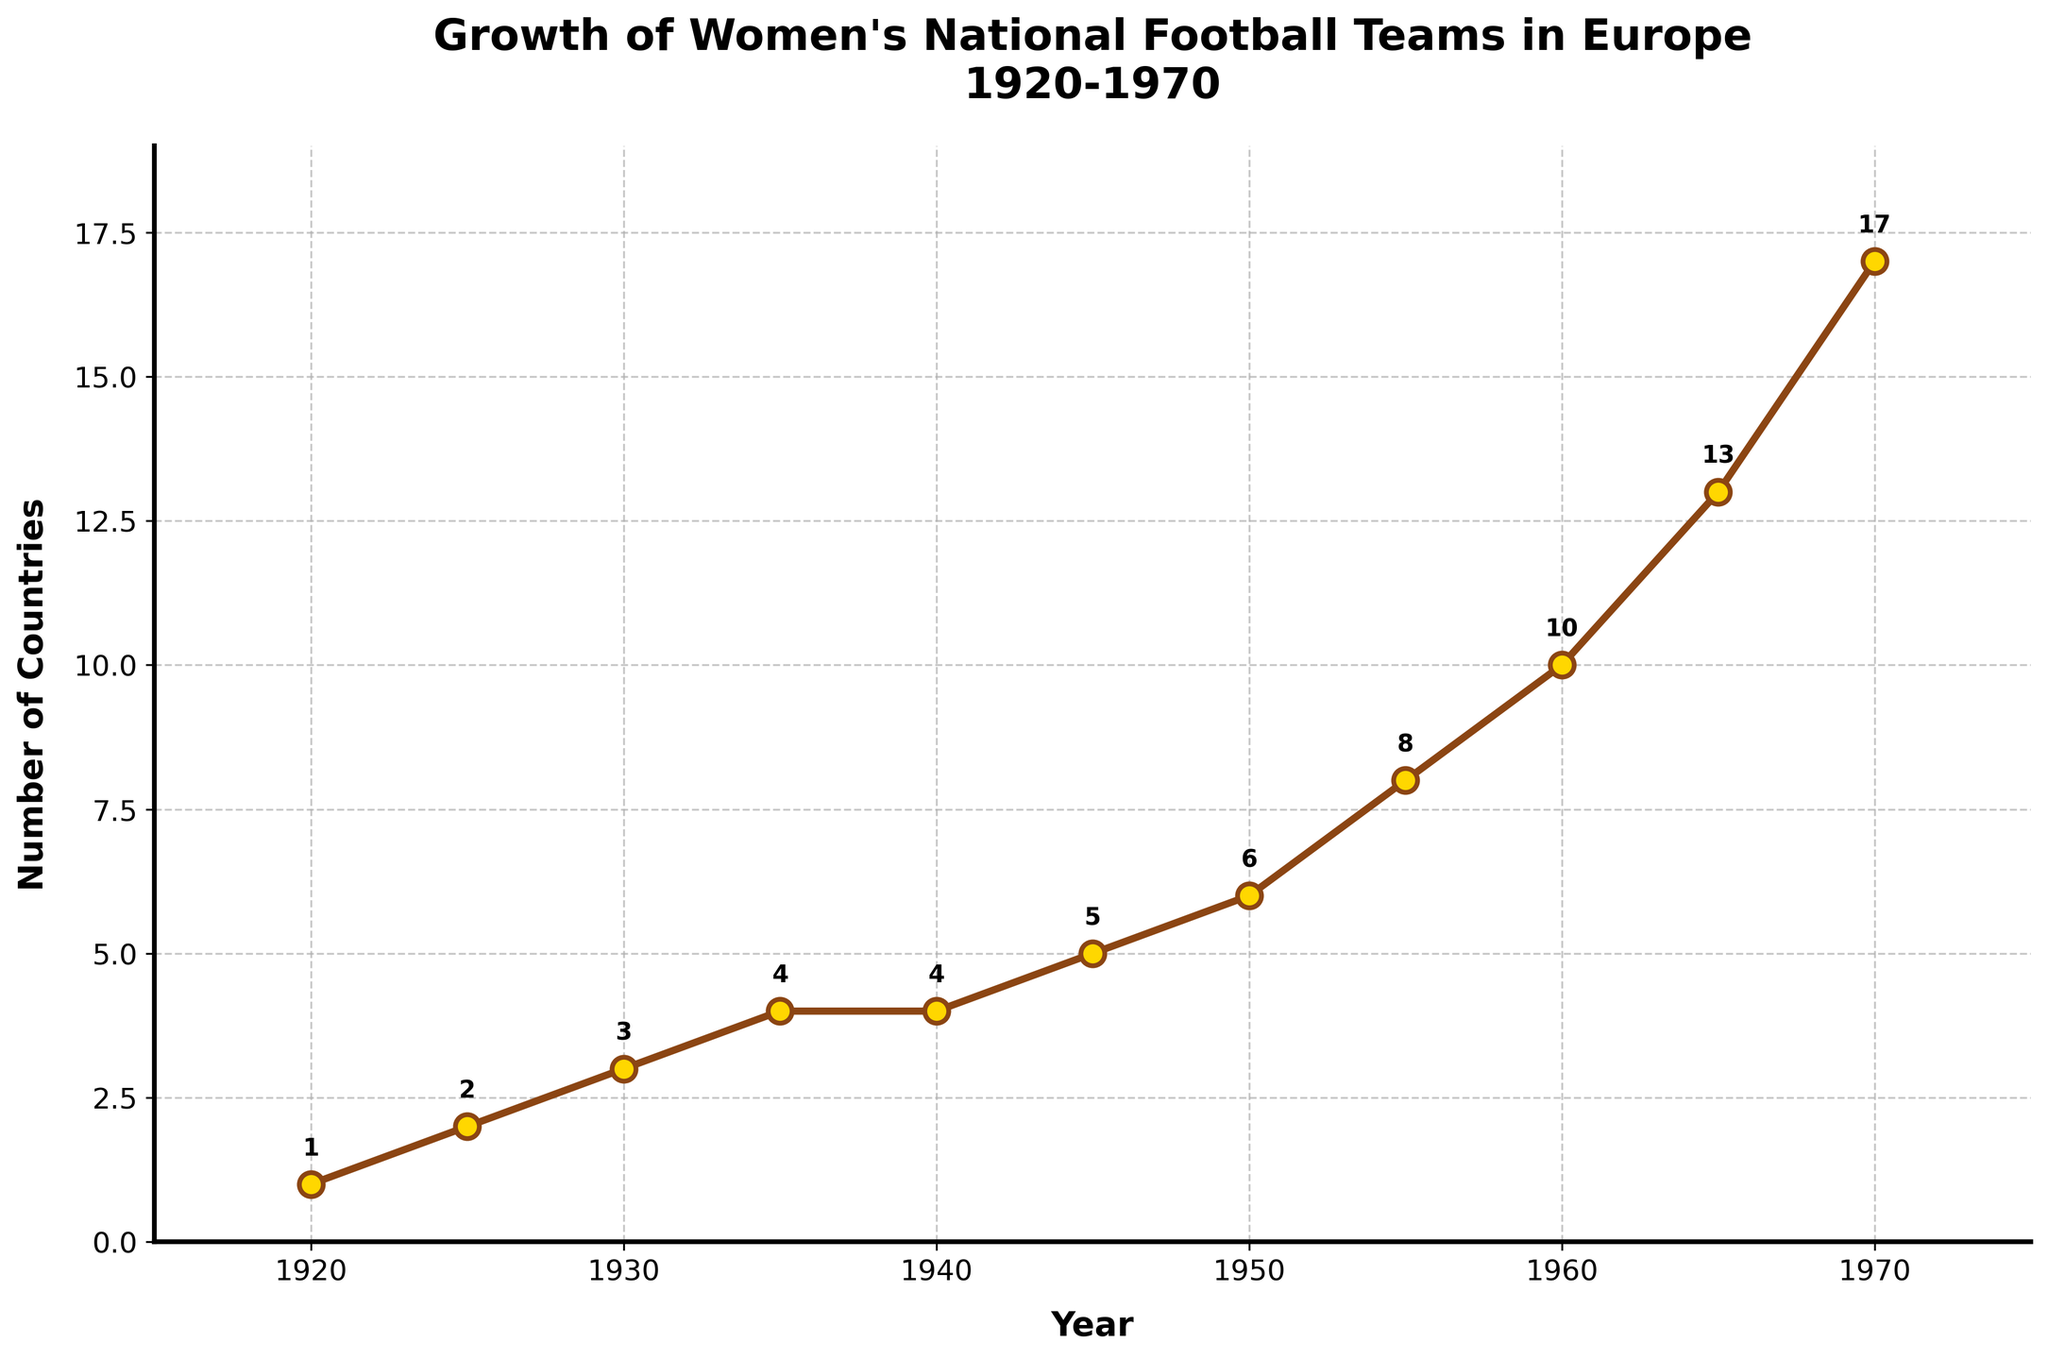Which year saw the biggest increase in the number of countries with official women's national football teams? To find the year with the biggest increase, we need to look at the differences between consecutive years. The difference between 1965 and 1970 is the largest (4 countries).
Answer: 1965 to 1970 How many countries had official women's national football teams by 1940? Look at the data point for the year 1940. The figure shows 4 countries by 1940.
Answer: 4 What was the average number of countries with teams between 1920 and 1930, inclusive? Sum the number of countries from 1920, 1925, and 1930 (1 + 2 + 3 = 6), then divide by 3 (years): 6 / 3 = 2
Answer: 2 By how much did the number of countries increase from 1950 to 1955? Subtract the value in 1950 from the value in 1955 (8 - 6 = 2).
Answer: 2 Did any periods see no increase in the number of countries? If yes, which? Examine the data and find years where consecutive data points are equal. 1940 and 1935 both have the same number of countries: 4.
Answer: Yes, 1935 to 1940 In which decade did the number of women's national football teams grow the fastest? Compare the increase in number of countries in each decade: the 1960s saw the largest increase (17 - 10 = 7).
Answer: 1960s How many countries added women's national football teams between 1945 and 1970? Subtract the number of countries in 1945 from that in 1970 (17 - 5 = 12).
Answer: 12 Was there ever a decrease in the number of countries with official women's national teams? Look through the entire data span for any declines or drops in the number of countries from one year to the next. The figure shows a consistent increase or stability with no decrease.
Answer: No Between which years did the number of countries grow linearly (by the same amount each interval)? Look for periods with a constant increase in the number of countries. From 1920 to 1930, every 5 years the count increases by 1.
Answer: 1920 to 1930 